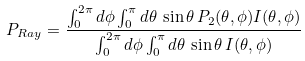Convert formula to latex. <formula><loc_0><loc_0><loc_500><loc_500>P _ { R a y } = \frac { \int _ { 0 } ^ { 2 \pi } d \phi \int _ { 0 } ^ { \pi } d \theta \, \sin \theta \, P _ { 2 } ( \theta , \phi ) I ( \theta , \phi ) } { \int _ { 0 } ^ { 2 \pi } d \phi \int _ { 0 } ^ { \pi } d \theta \, \sin \theta \, I ( \theta , \phi ) }</formula> 